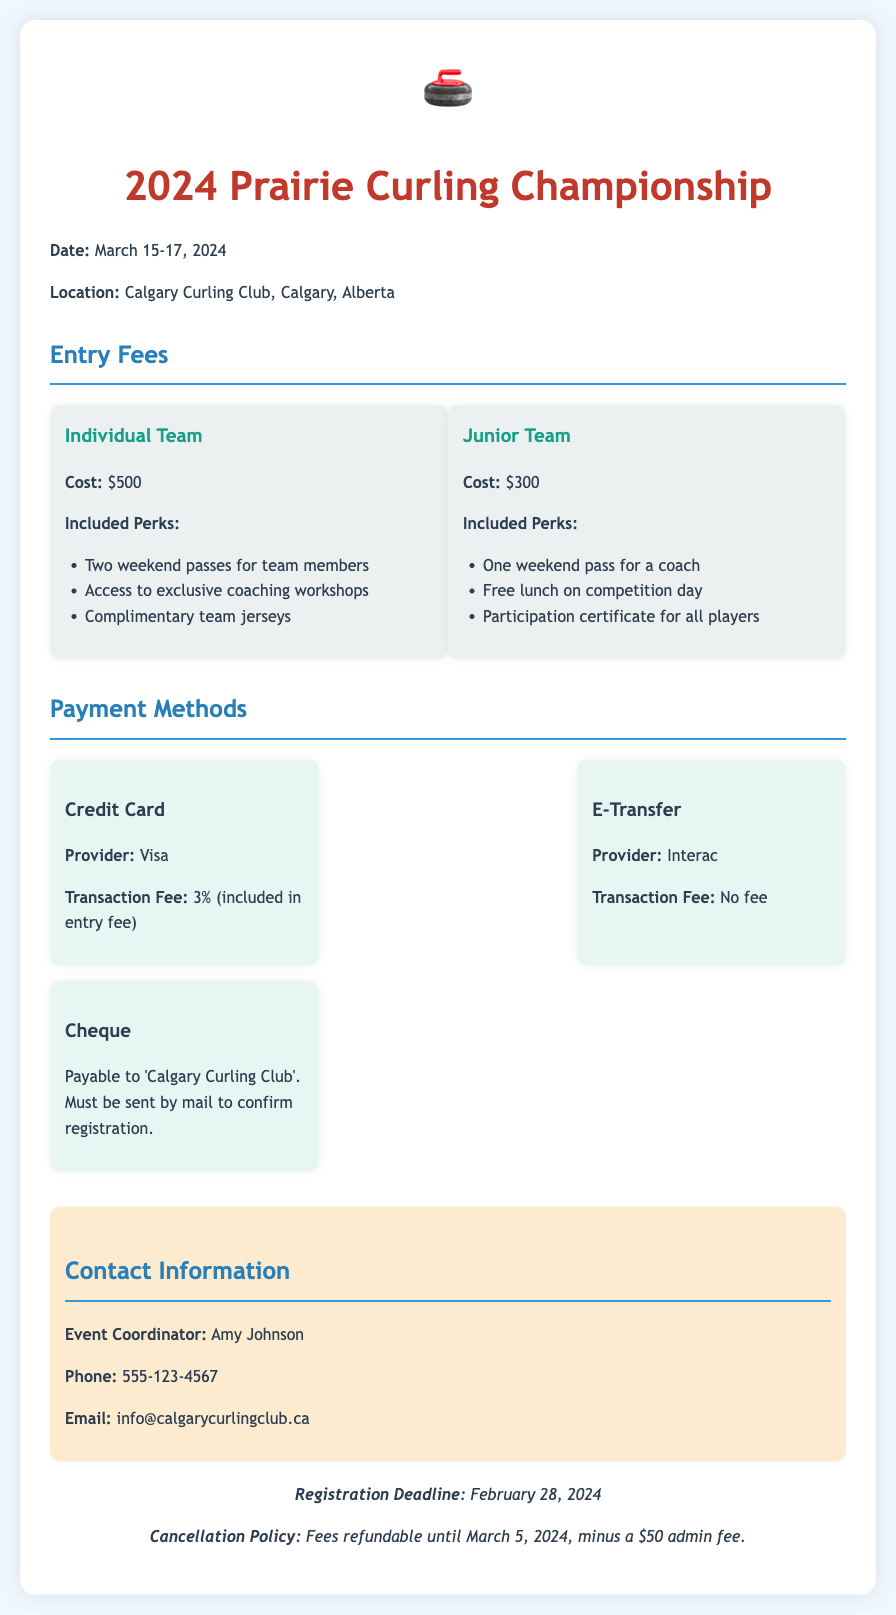What are the dates of the tournament? The tournament dates are explicitly mentioned in the document as March 15-17, 2024.
Answer: March 15-17, 2024 What is the entry fee for an Individual Team? The document specifies the cost for an Individual Team as $500.
Answer: $500 What perks are included for a Junior Team? The document lists the included perks for a Junior Team, which are one weekend pass for a coach, free lunch, and participation certificate.
Answer: One weekend pass for a coach, free lunch, participation certificate Which payment method has no transaction fee? The document indicates that the E-Transfer via Interac has no transaction fee.
Answer: E-Transfer What is the cancellation policy? The cancellation policy states that fees are refundable until March 5, 2024, minus a $50 admin fee.
Answer: Fees refundable until March 5, 2024, minus a $50 admin fee What is the registration deadline? The registration deadline is stated in the document as February 28, 2024.
Answer: February 28, 2024 Who is the event coordinator? The document provides the name of the event coordinator as Amy Johnson.
Answer: Amy Johnson What is the transaction fee for credit card payments? The document specifies a transaction fee of 3% for credit card payments.
Answer: 3% 